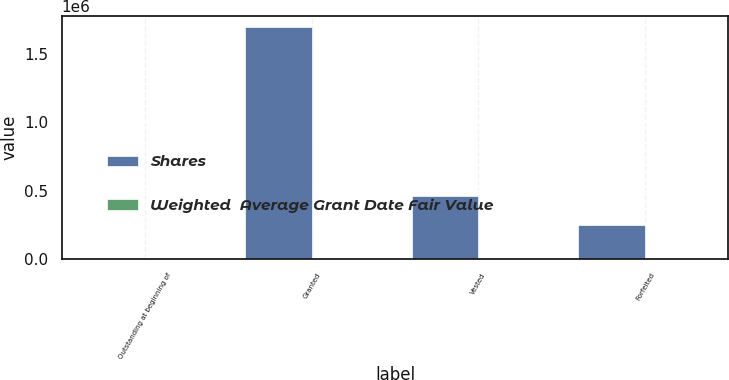Convert chart to OTSL. <chart><loc_0><loc_0><loc_500><loc_500><stacked_bar_chart><ecel><fcel>Outstanding at beginning of<fcel>Granted<fcel>Vested<fcel>Forfeited<nl><fcel>Shares<fcel>239<fcel>1.69467e+06<fcel>460032<fcel>244227<nl><fcel>Weighted  Average Grant Date Fair Value<fcel>239<fcel>61<fcel>14<fcel>9<nl></chart> 